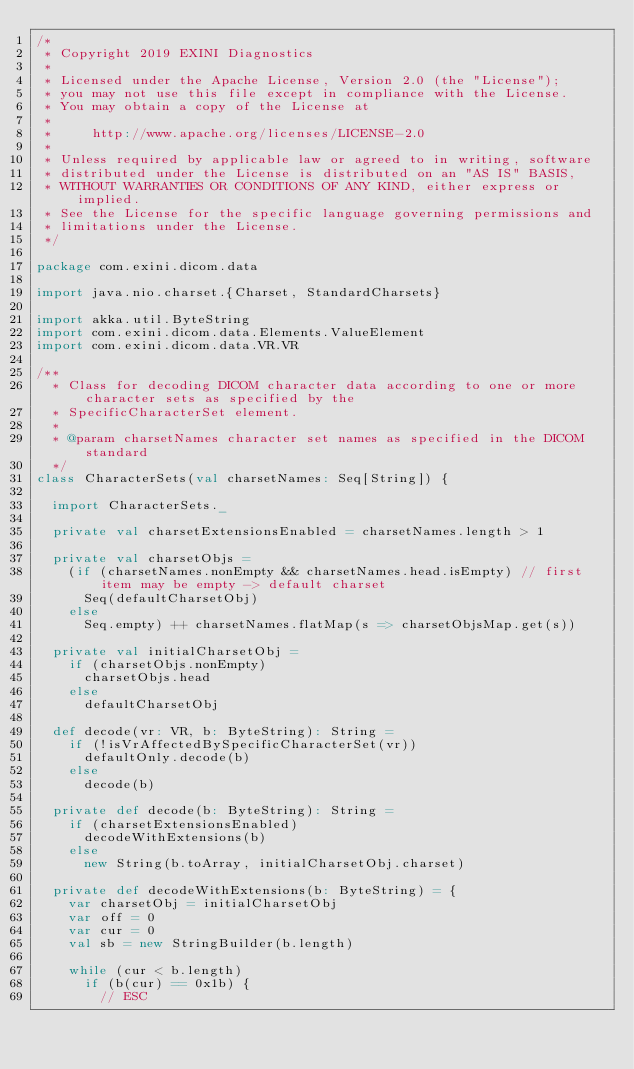Convert code to text. <code><loc_0><loc_0><loc_500><loc_500><_Scala_>/*
 * Copyright 2019 EXINI Diagnostics
 *
 * Licensed under the Apache License, Version 2.0 (the "License");
 * you may not use this file except in compliance with the License.
 * You may obtain a copy of the License at
 *
 *     http://www.apache.org/licenses/LICENSE-2.0
 *
 * Unless required by applicable law or agreed to in writing, software
 * distributed under the License is distributed on an "AS IS" BASIS,
 * WITHOUT WARRANTIES OR CONDITIONS OF ANY KIND, either express or implied.
 * See the License for the specific language governing permissions and
 * limitations under the License.
 */

package com.exini.dicom.data

import java.nio.charset.{Charset, StandardCharsets}

import akka.util.ByteString
import com.exini.dicom.data.Elements.ValueElement
import com.exini.dicom.data.VR.VR

/**
  * Class for decoding DICOM character data according to one or more character sets as specified by the
  * SpecificCharacterSet element.
  *
  * @param charsetNames character set names as specified in the DICOM standard
  */
class CharacterSets(val charsetNames: Seq[String]) {

  import CharacterSets._

  private val charsetExtensionsEnabled = charsetNames.length > 1

  private val charsetObjs =
    (if (charsetNames.nonEmpty && charsetNames.head.isEmpty) // first item may be empty -> default charset
      Seq(defaultCharsetObj)
    else
      Seq.empty) ++ charsetNames.flatMap(s => charsetObjsMap.get(s))

  private val initialCharsetObj =
    if (charsetObjs.nonEmpty)
      charsetObjs.head
    else
      defaultCharsetObj

  def decode(vr: VR, b: ByteString): String =
    if (!isVrAffectedBySpecificCharacterSet(vr))
      defaultOnly.decode(b)
    else
      decode(b)

  private def decode(b: ByteString): String =
    if (charsetExtensionsEnabled)
      decodeWithExtensions(b)
    else
      new String(b.toArray, initialCharsetObj.charset)

  private def decodeWithExtensions(b: ByteString) = {
    var charsetObj = initialCharsetObj
    var off = 0
    var cur = 0
    val sb = new StringBuilder(b.length)

    while (cur < b.length)
      if (b(cur) == 0x1b) {
        // ESC</code> 